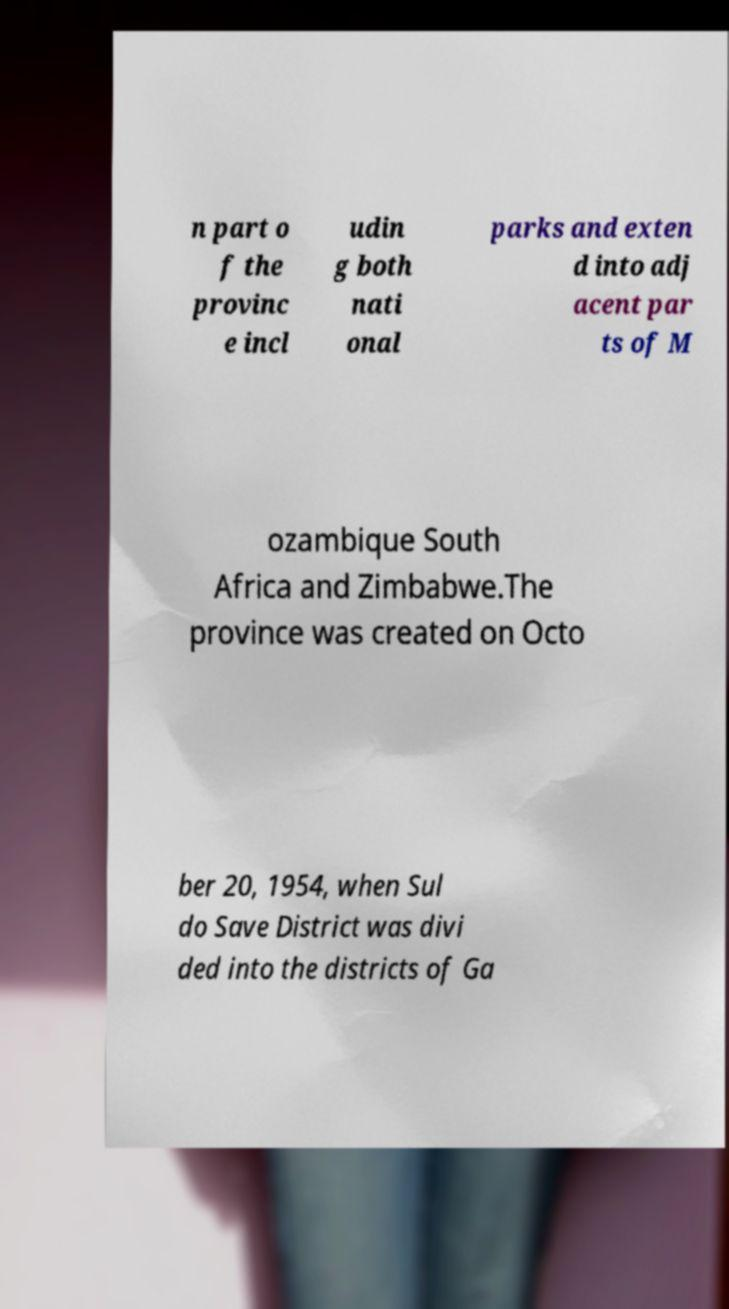There's text embedded in this image that I need extracted. Can you transcribe it verbatim? n part o f the provinc e incl udin g both nati onal parks and exten d into adj acent par ts of M ozambique South Africa and Zimbabwe.The province was created on Octo ber 20, 1954, when Sul do Save District was divi ded into the districts of Ga 